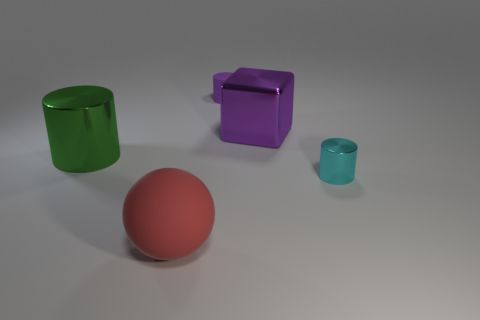What size is the thing that is the same color as the large block?
Offer a terse response. Small. What number of spheres are either shiny things or red things?
Provide a short and direct response. 1. Is there any other thing that has the same color as the sphere?
Give a very brief answer. No. The small cylinder in front of the metal cylinder on the left side of the large red object is made of what material?
Your answer should be very brief. Metal. Is the large red thing made of the same material as the thing on the left side of the red object?
Offer a very short reply. No. What number of objects are either big things right of the red matte sphere or small red matte cylinders?
Provide a succinct answer. 1. Are there any tiny objects that have the same color as the large cube?
Ensure brevity in your answer.  Yes. Does the cyan thing have the same shape as the large shiny thing that is to the left of the big purple object?
Offer a very short reply. Yes. What number of shiny objects are left of the small cyan cylinder and in front of the big purple cube?
Provide a succinct answer. 1. There is a tiny cyan thing that is the same shape as the green object; what material is it?
Make the answer very short. Metal. 